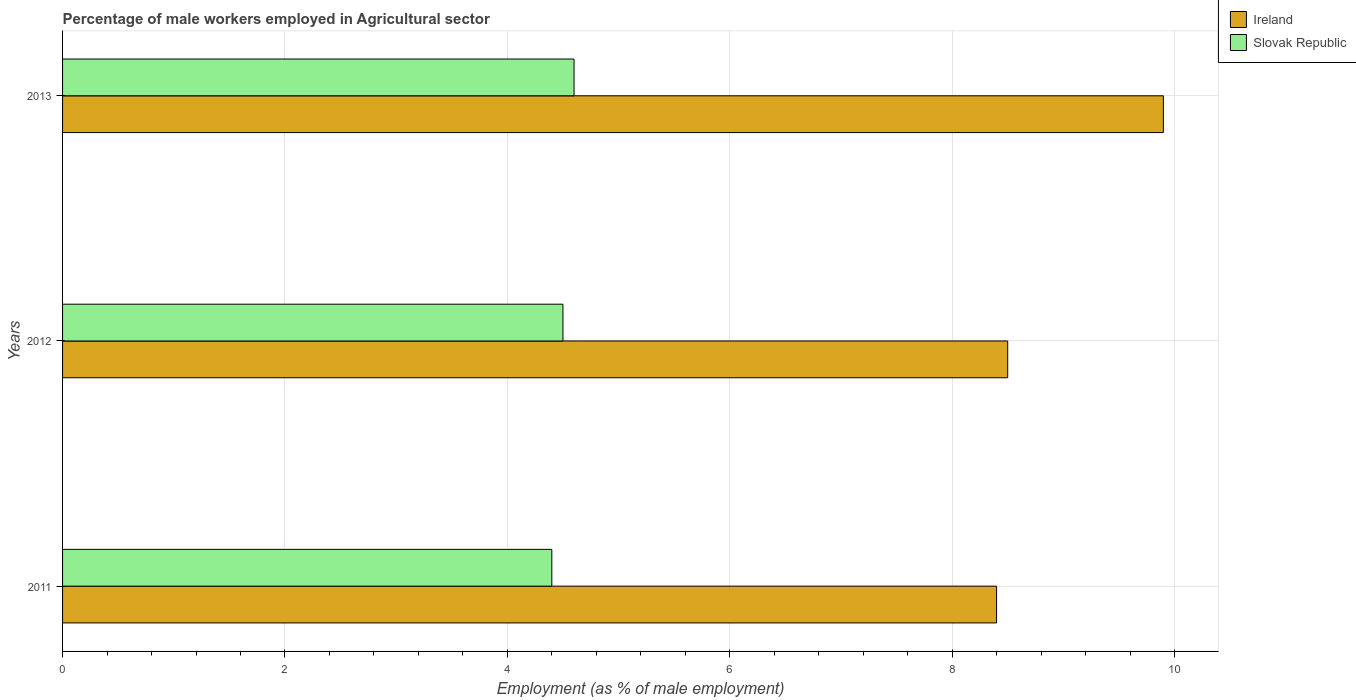Are the number of bars on each tick of the Y-axis equal?
Make the answer very short. Yes. How many bars are there on the 1st tick from the top?
Your response must be concise. 2. What is the label of the 2nd group of bars from the top?
Make the answer very short. 2012. What is the percentage of male workers employed in Agricultural sector in Ireland in 2013?
Ensure brevity in your answer.  9.9. Across all years, what is the maximum percentage of male workers employed in Agricultural sector in Slovak Republic?
Provide a short and direct response. 4.6. Across all years, what is the minimum percentage of male workers employed in Agricultural sector in Slovak Republic?
Keep it short and to the point. 4.4. In which year was the percentage of male workers employed in Agricultural sector in Slovak Republic minimum?
Your answer should be compact. 2011. What is the total percentage of male workers employed in Agricultural sector in Ireland in the graph?
Your answer should be compact. 26.8. What is the difference between the percentage of male workers employed in Agricultural sector in Slovak Republic in 2011 and that in 2013?
Ensure brevity in your answer.  -0.2. What is the difference between the percentage of male workers employed in Agricultural sector in Slovak Republic in 2011 and the percentage of male workers employed in Agricultural sector in Ireland in 2012?
Offer a very short reply. -4.1. In the year 2011, what is the difference between the percentage of male workers employed in Agricultural sector in Slovak Republic and percentage of male workers employed in Agricultural sector in Ireland?
Your answer should be very brief. -4. What is the ratio of the percentage of male workers employed in Agricultural sector in Ireland in 2012 to that in 2013?
Your answer should be compact. 0.86. What is the difference between the highest and the second highest percentage of male workers employed in Agricultural sector in Slovak Republic?
Keep it short and to the point. 0.1. What is the difference between the highest and the lowest percentage of male workers employed in Agricultural sector in Ireland?
Provide a short and direct response. 1.5. What does the 1st bar from the top in 2012 represents?
Give a very brief answer. Slovak Republic. What does the 2nd bar from the bottom in 2013 represents?
Provide a short and direct response. Slovak Republic. How many bars are there?
Your answer should be compact. 6. Are all the bars in the graph horizontal?
Provide a short and direct response. Yes. Are the values on the major ticks of X-axis written in scientific E-notation?
Provide a succinct answer. No. Where does the legend appear in the graph?
Keep it short and to the point. Top right. How many legend labels are there?
Ensure brevity in your answer.  2. How are the legend labels stacked?
Give a very brief answer. Vertical. What is the title of the graph?
Your response must be concise. Percentage of male workers employed in Agricultural sector. Does "Vietnam" appear as one of the legend labels in the graph?
Your response must be concise. No. What is the label or title of the X-axis?
Your response must be concise. Employment (as % of male employment). What is the label or title of the Y-axis?
Provide a short and direct response. Years. What is the Employment (as % of male employment) of Ireland in 2011?
Your answer should be very brief. 8.4. What is the Employment (as % of male employment) in Slovak Republic in 2011?
Offer a very short reply. 4.4. What is the Employment (as % of male employment) in Ireland in 2012?
Your answer should be very brief. 8.5. What is the Employment (as % of male employment) in Slovak Republic in 2012?
Give a very brief answer. 4.5. What is the Employment (as % of male employment) in Ireland in 2013?
Your response must be concise. 9.9. What is the Employment (as % of male employment) in Slovak Republic in 2013?
Provide a short and direct response. 4.6. Across all years, what is the maximum Employment (as % of male employment) of Ireland?
Your answer should be very brief. 9.9. Across all years, what is the maximum Employment (as % of male employment) in Slovak Republic?
Make the answer very short. 4.6. Across all years, what is the minimum Employment (as % of male employment) in Ireland?
Ensure brevity in your answer.  8.4. Across all years, what is the minimum Employment (as % of male employment) in Slovak Republic?
Your answer should be compact. 4.4. What is the total Employment (as % of male employment) of Ireland in the graph?
Your response must be concise. 26.8. What is the total Employment (as % of male employment) in Slovak Republic in the graph?
Provide a succinct answer. 13.5. What is the difference between the Employment (as % of male employment) in Ireland in 2011 and that in 2012?
Give a very brief answer. -0.1. What is the difference between the Employment (as % of male employment) of Ireland in 2012 and that in 2013?
Your response must be concise. -1.4. What is the difference between the Employment (as % of male employment) of Slovak Republic in 2012 and that in 2013?
Provide a short and direct response. -0.1. What is the difference between the Employment (as % of male employment) in Ireland in 2011 and the Employment (as % of male employment) in Slovak Republic in 2012?
Give a very brief answer. 3.9. What is the difference between the Employment (as % of male employment) of Ireland in 2012 and the Employment (as % of male employment) of Slovak Republic in 2013?
Offer a very short reply. 3.9. What is the average Employment (as % of male employment) of Ireland per year?
Provide a succinct answer. 8.93. What is the average Employment (as % of male employment) in Slovak Republic per year?
Offer a very short reply. 4.5. What is the ratio of the Employment (as % of male employment) in Slovak Republic in 2011 to that in 2012?
Make the answer very short. 0.98. What is the ratio of the Employment (as % of male employment) in Ireland in 2011 to that in 2013?
Offer a terse response. 0.85. What is the ratio of the Employment (as % of male employment) of Slovak Republic in 2011 to that in 2013?
Make the answer very short. 0.96. What is the ratio of the Employment (as % of male employment) in Ireland in 2012 to that in 2013?
Give a very brief answer. 0.86. What is the ratio of the Employment (as % of male employment) in Slovak Republic in 2012 to that in 2013?
Make the answer very short. 0.98. What is the difference between the highest and the lowest Employment (as % of male employment) in Ireland?
Provide a succinct answer. 1.5. 